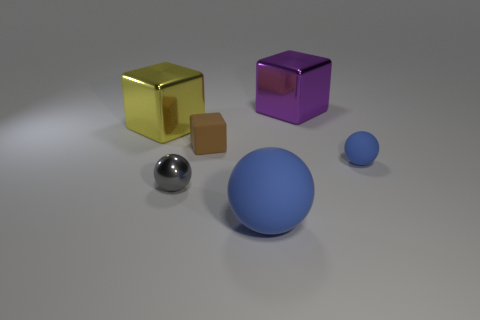Add 2 small brown matte objects. How many objects exist? 8 Subtract all purple cubes. Subtract all brown rubber things. How many objects are left? 4 Add 1 tiny things. How many tiny things are left? 4 Add 6 yellow shiny objects. How many yellow shiny objects exist? 7 Subtract 0 yellow balls. How many objects are left? 6 